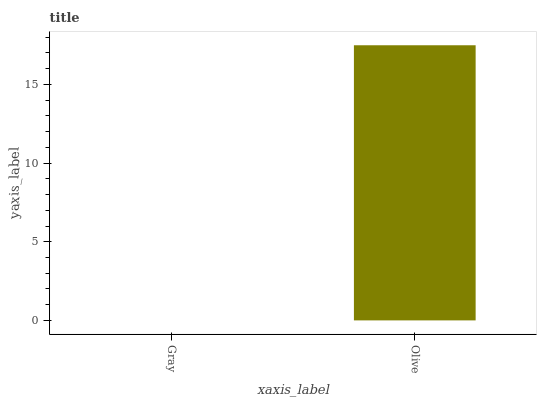Is Olive the minimum?
Answer yes or no. No. Is Olive greater than Gray?
Answer yes or no. Yes. Is Gray less than Olive?
Answer yes or no. Yes. Is Gray greater than Olive?
Answer yes or no. No. Is Olive less than Gray?
Answer yes or no. No. Is Olive the high median?
Answer yes or no. Yes. Is Gray the low median?
Answer yes or no. Yes. Is Gray the high median?
Answer yes or no. No. Is Olive the low median?
Answer yes or no. No. 